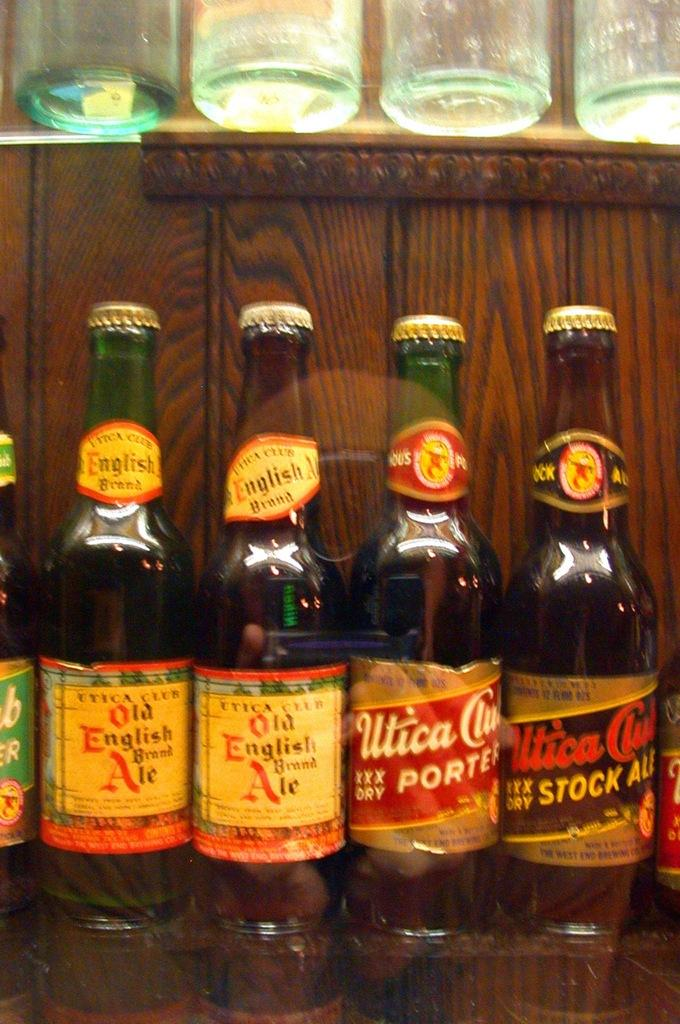<image>
Offer a succinct explanation of the picture presented. Five beer bottles sit together including two Old English Brewed Ale. 